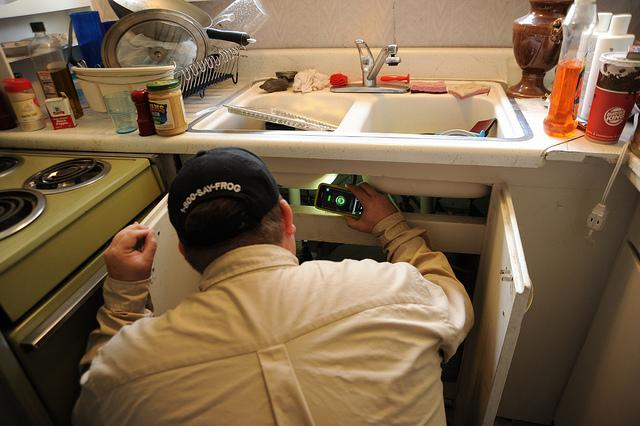What is the man using the phone as? flashlight 